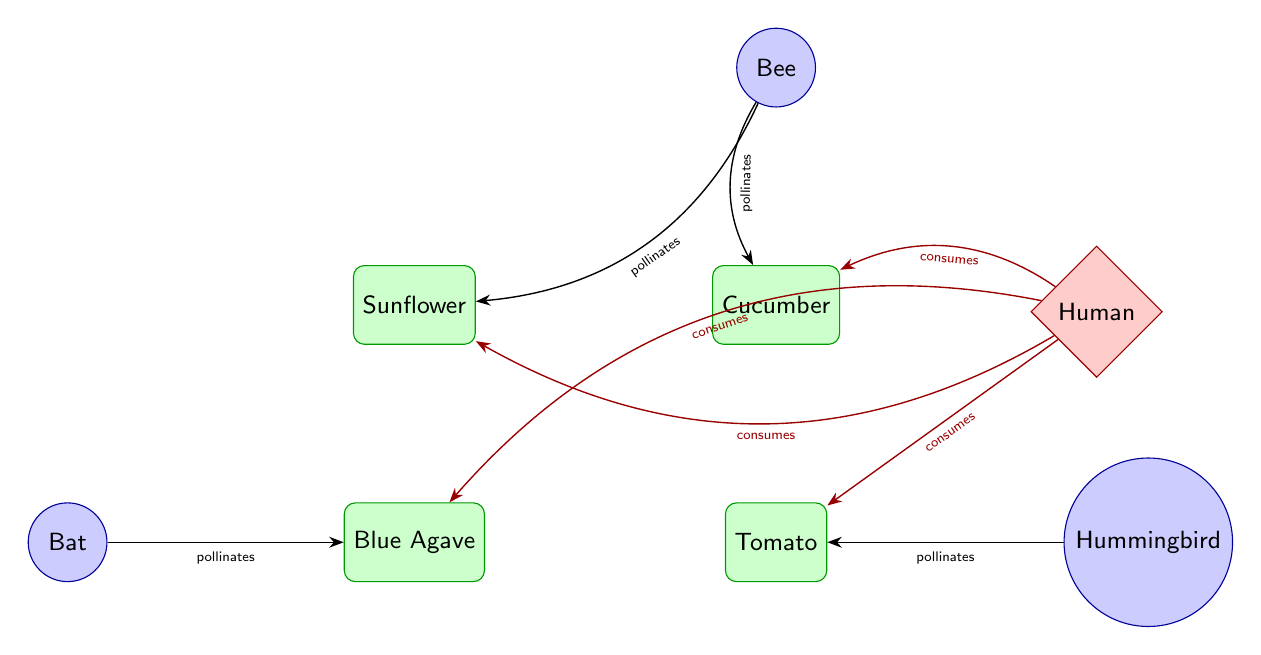What is the role of a bee in this food web? The bee is shown as a pollinator that contributes to the pollination of both the sunflower and cucumber in the diagram. This determines its essential role in facilitating the growth of these plants.
Answer: pollinates How many pollinators are represented in the diagram? By counting the nodes labeled as pollinators in the diagram, we determine there are three: bee, hummingbird, and bat. Therefore, the answer comes from visually inspecting the pollinator nodes.
Answer: 3 Which plant does the bat pollinate? The bat is directed towards the blue agave in the diagram through an arrow indicating the relationship of pollination. Hence, following the arrow confirms this relationship.
Answer: blue agave Who consumes the cucumber? The diagram indicates that the human node has arrows pointing towards the cucumber, indicating the consumption relationship. Tracking the arrows shows the human's connection to this plant.
Answer: Human What type of relationship is shown between the human and sunflower? The arrow from the human to the sunflower is colored red and labeled with "consumes," indicating a consumption relationship. Analyzing the relationship through the directed arrow conveys human dietary interaction with the sunflower.
Answer: consumes How many plants are in the diagram? The plant nodes are sunflower, cucumber, tomato, and blue agave, which can be counted directly from the diagram. Thus, tallying these nodes gives the total number of plants present.
Answer: 4 What type of diagram is presented here? This diagram represents a food web, which is characterized by displaying the interconnections between different organisms, specifically illustrating the relationships among plants, pollinators, and consumers. The formatting and relationships indicate a food chain's specific nature.
Answer: food web Which pollinator is associated with the tomato? The hummingbird is indicated by the directed arrow that points to the tomato plant, showing its specific role in pollinating this plant. Following the visual connection reveals this direct interaction.
Answer: Hummingbird What is the role of the hummingbird in relation to the food web? The hummingbird is responsible for the pollination of the tomato. This is clear from the connection labeled "pollinates," specifically illustrating the function of the hummingbird in enhancing plant reproduction.
Answer: pollinates 